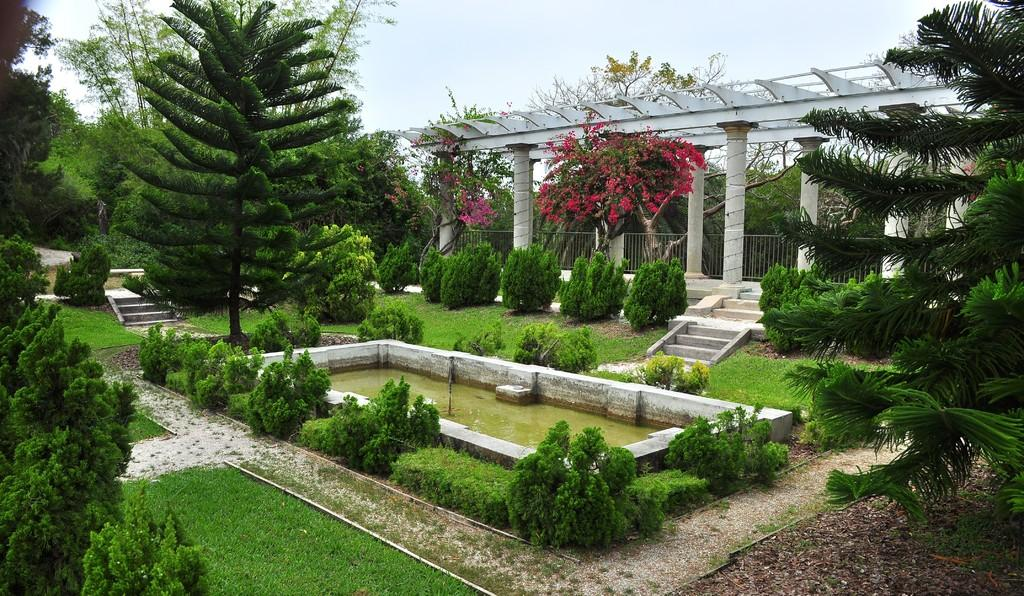What type of vegetation can be seen in the image? There are green trees in the image. What architectural feature is present in the image? There are stairs in the image. What type of flowers are visible in the image? There are pink flowers in the image. What natural element can be seen in the image? There is water visible in the image. What type of barrier is present in the image? There is fencing in the image. What structural element can be seen in the image? There are pillars in the image. What is the color of the sky in the image? The sky is blue and white in color. How many jelly containers are visible in the image? There are no jelly containers present in the image. What type of clouds can be seen in the image? There is no mention of clouds in the image; only the blue and white sky is described. How many passengers are visible in the image? There is no mention of passengers in the image. 